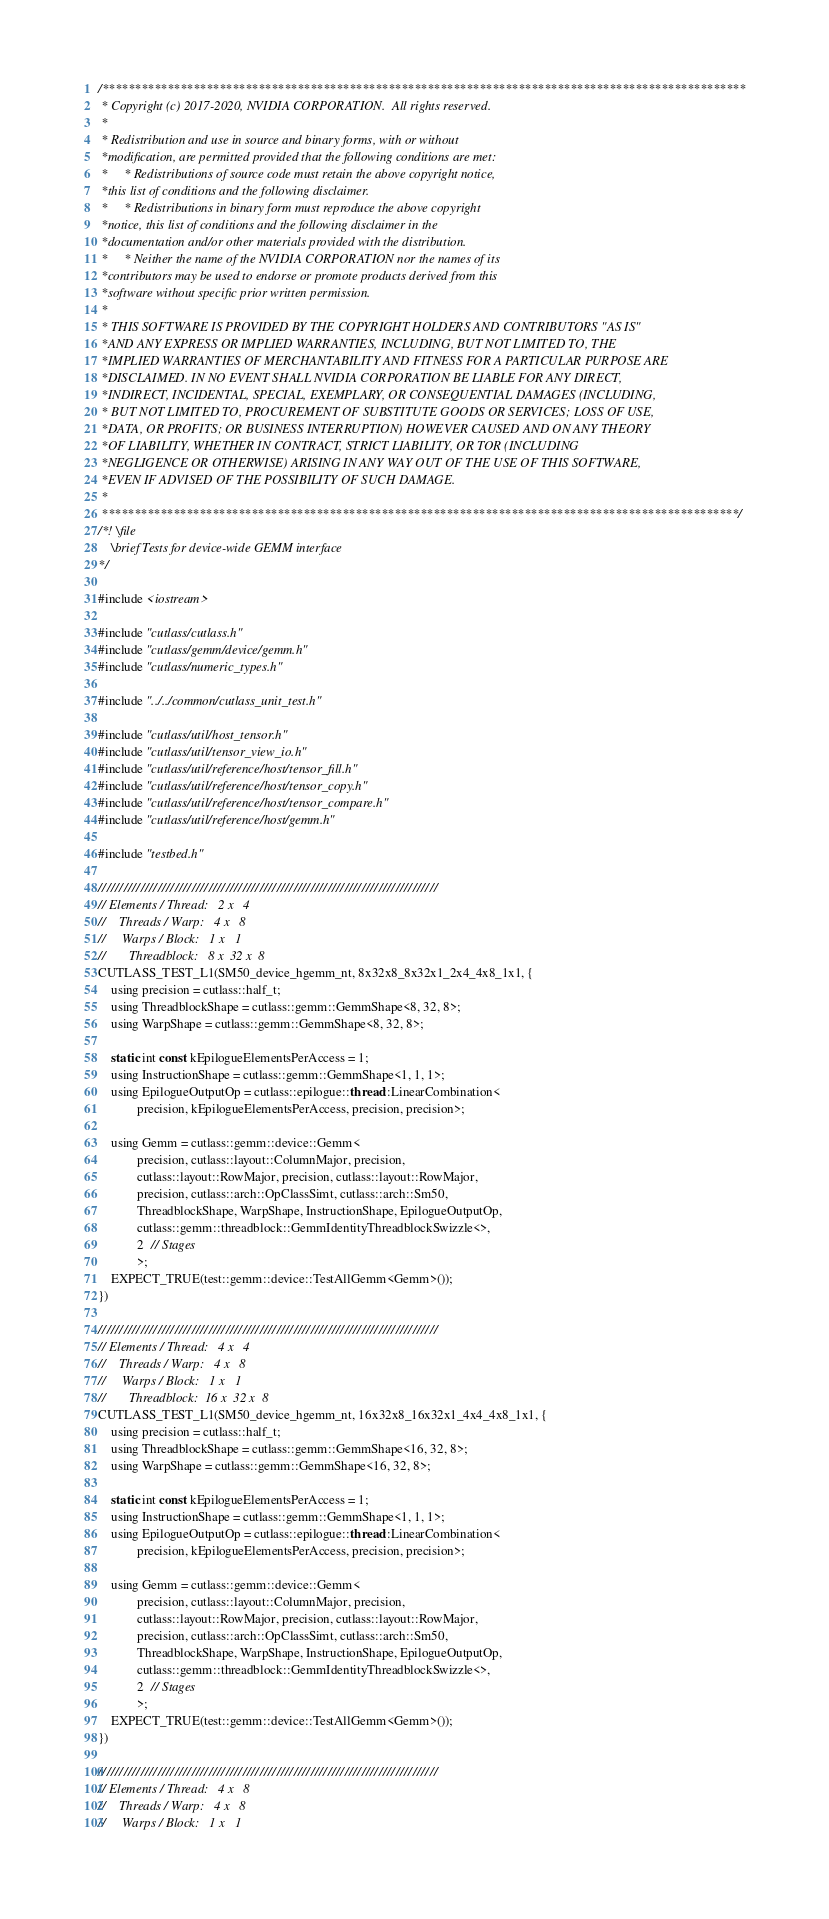Convert code to text. <code><loc_0><loc_0><loc_500><loc_500><_Cuda_>/***************************************************************************************************
 * Copyright (c) 2017-2020, NVIDIA CORPORATION.  All rights reserved.
 *
 * Redistribution and use in source and binary forms, with or without
 *modification, are permitted provided that the following conditions are met:
 *     * Redistributions of source code must retain the above copyright notice,
 *this list of conditions and the following disclaimer.
 *     * Redistributions in binary form must reproduce the above copyright
 *notice, this list of conditions and the following disclaimer in the
 *documentation and/or other materials provided with the distribution.
 *     * Neither the name of the NVIDIA CORPORATION nor the names of its
 *contributors may be used to endorse or promote products derived from this
 *software without specific prior written permission.
 *
 * THIS SOFTWARE IS PROVIDED BY THE COPYRIGHT HOLDERS AND CONTRIBUTORS "AS IS"
 *AND ANY EXPRESS OR IMPLIED WARRANTIES, INCLUDING, BUT NOT LIMITED TO, THE
 *IMPLIED WARRANTIES OF MERCHANTABILITY AND FITNESS FOR A PARTICULAR PURPOSE ARE
 *DISCLAIMED. IN NO EVENT SHALL NVIDIA CORPORATION BE LIABLE FOR ANY DIRECT,
 *INDIRECT, INCIDENTAL, SPECIAL, EXEMPLARY, OR CONSEQUENTIAL DAMAGES (INCLUDING,
 * BUT NOT LIMITED TO, PROCUREMENT OF SUBSTITUTE GOODS OR SERVICES; LOSS OF USE,
 *DATA, OR PROFITS; OR BUSINESS INTERRUPTION) HOWEVER CAUSED AND ON ANY THEORY
 *OF LIABILITY, WHETHER IN CONTRACT, STRICT LIABILITY, OR TOR (INCLUDING
 *NEGLIGENCE OR OTHERWISE) ARISING IN ANY WAY OUT OF THE USE OF THIS SOFTWARE,
 *EVEN IF ADVISED OF THE POSSIBILITY OF SUCH DAMAGE.
 *
 **************************************************************************************************/
/*! \file
    \brief Tests for device-wide GEMM interface
*/

#include <iostream>

#include "cutlass/cutlass.h"
#include "cutlass/gemm/device/gemm.h"
#include "cutlass/numeric_types.h"

#include "../../common/cutlass_unit_test.h"

#include "cutlass/util/host_tensor.h"
#include "cutlass/util/tensor_view_io.h"
#include "cutlass/util/reference/host/tensor_fill.h"
#include "cutlass/util/reference/host/tensor_copy.h"
#include "cutlass/util/reference/host/tensor_compare.h"
#include "cutlass/util/reference/host/gemm.h"

#include "testbed.h"

////////////////////////////////////////////////////////////////////////////////
// Elements / Thread:   2 x   4
//    Threads / Warp:   4 x   8
//     Warps / Block:   1 x   1
//       Threadblock:   8 x  32 x  8
CUTLASS_TEST_L1(SM50_device_hgemm_nt, 8x32x8_8x32x1_2x4_4x8_1x1, {
    using precision = cutlass::half_t;
    using ThreadblockShape = cutlass::gemm::GemmShape<8, 32, 8>;
    using WarpShape = cutlass::gemm::GemmShape<8, 32, 8>;

    static int const kEpilogueElementsPerAccess = 1;
    using InstructionShape = cutlass::gemm::GemmShape<1, 1, 1>;
    using EpilogueOutputOp = cutlass::epilogue::thread::LinearCombination<
            precision, kEpilogueElementsPerAccess, precision, precision>;

    using Gemm = cutlass::gemm::device::Gemm<
            precision, cutlass::layout::ColumnMajor, precision,
            cutlass::layout::RowMajor, precision, cutlass::layout::RowMajor,
            precision, cutlass::arch::OpClassSimt, cutlass::arch::Sm50,
            ThreadblockShape, WarpShape, InstructionShape, EpilogueOutputOp,
            cutlass::gemm::threadblock::GemmIdentityThreadblockSwizzle<>,
            2  // Stages
            >;
    EXPECT_TRUE(test::gemm::device::TestAllGemm<Gemm>());
})

////////////////////////////////////////////////////////////////////////////////
// Elements / Thread:   4 x   4
//    Threads / Warp:   4 x   8
//     Warps / Block:   1 x   1
//       Threadblock:  16 x  32 x  8
CUTLASS_TEST_L1(SM50_device_hgemm_nt, 16x32x8_16x32x1_4x4_4x8_1x1, {
    using precision = cutlass::half_t;
    using ThreadblockShape = cutlass::gemm::GemmShape<16, 32, 8>;
    using WarpShape = cutlass::gemm::GemmShape<16, 32, 8>;

    static int const kEpilogueElementsPerAccess = 1;
    using InstructionShape = cutlass::gemm::GemmShape<1, 1, 1>;
    using EpilogueOutputOp = cutlass::epilogue::thread::LinearCombination<
            precision, kEpilogueElementsPerAccess, precision, precision>;

    using Gemm = cutlass::gemm::device::Gemm<
            precision, cutlass::layout::ColumnMajor, precision,
            cutlass::layout::RowMajor, precision, cutlass::layout::RowMajor,
            precision, cutlass::arch::OpClassSimt, cutlass::arch::Sm50,
            ThreadblockShape, WarpShape, InstructionShape, EpilogueOutputOp,
            cutlass::gemm::threadblock::GemmIdentityThreadblockSwizzle<>,
            2  // Stages
            >;
    EXPECT_TRUE(test::gemm::device::TestAllGemm<Gemm>());
})

////////////////////////////////////////////////////////////////////////////////
// Elements / Thread:   4 x   8
//    Threads / Warp:   4 x   8
//     Warps / Block:   1 x   1</code> 